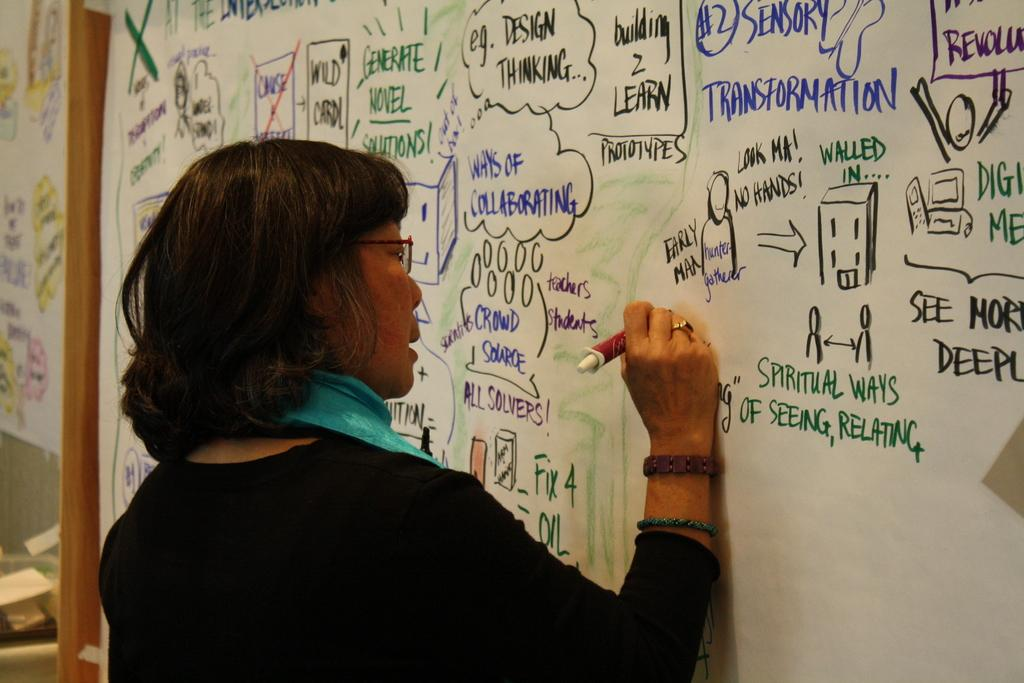<image>
Summarize the visual content of the image. A woman writes on a white board besides green writing that states, "Spiritual Ways." 